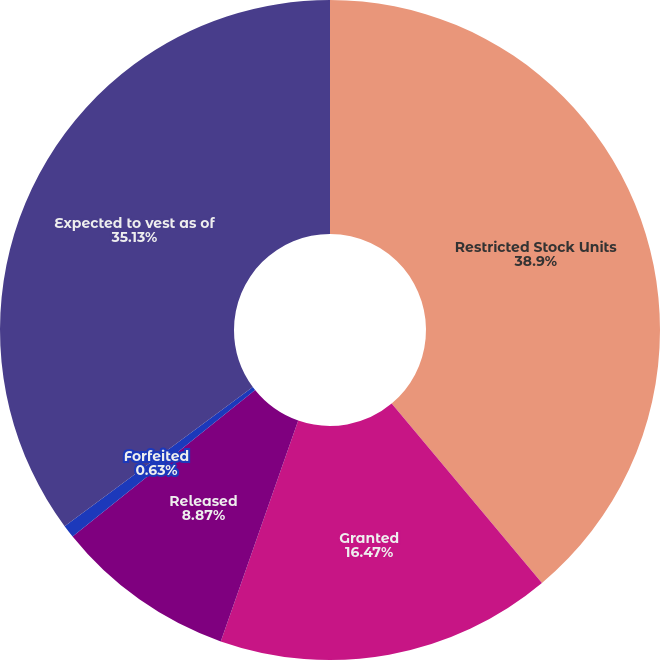Convert chart. <chart><loc_0><loc_0><loc_500><loc_500><pie_chart><fcel>Restricted Stock Units<fcel>Granted<fcel>Released<fcel>Forfeited<fcel>Expected to vest as of<nl><fcel>38.9%<fcel>16.47%<fcel>8.87%<fcel>0.63%<fcel>35.13%<nl></chart> 